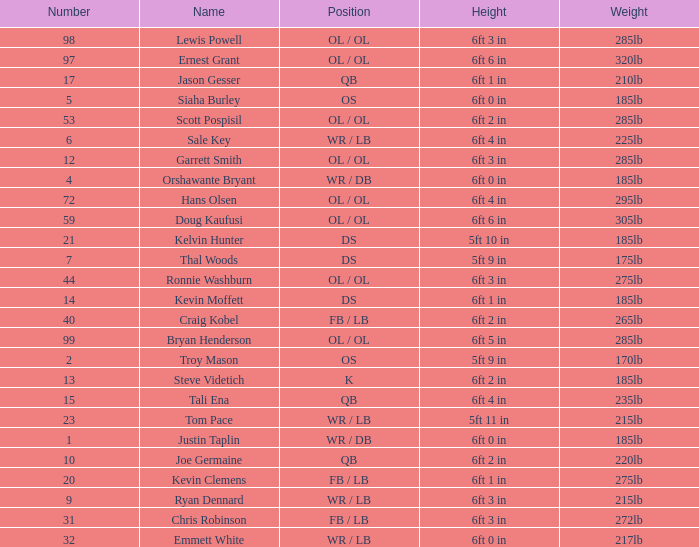What is the number for the player that has a k position? 13.0. 